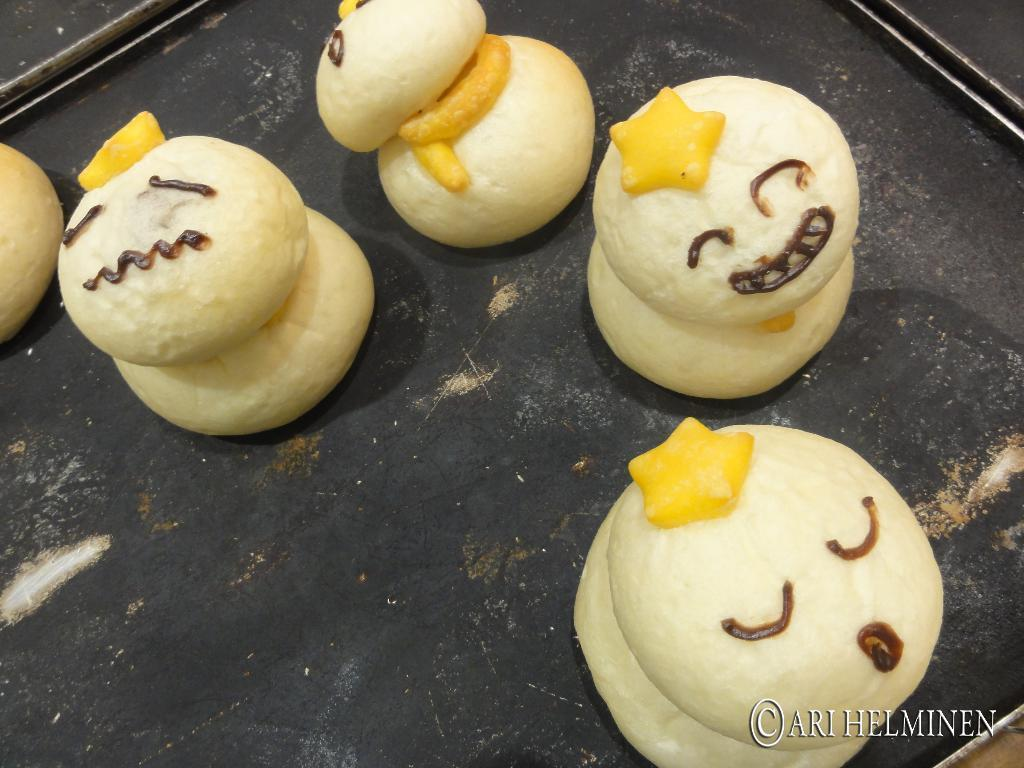What object is present in the image that can hold items? There is a tray in the image that can hold items. What is on the tray in the image? There is food on the tray in the image. Where can text be found in the image? The text is located at the right bottom of the image. What type of horn is being played in the image? There is no horn present in the image. What property is depicted in the image? The image does not show any property; it only features a tray with food and text at the bottom right corner. 